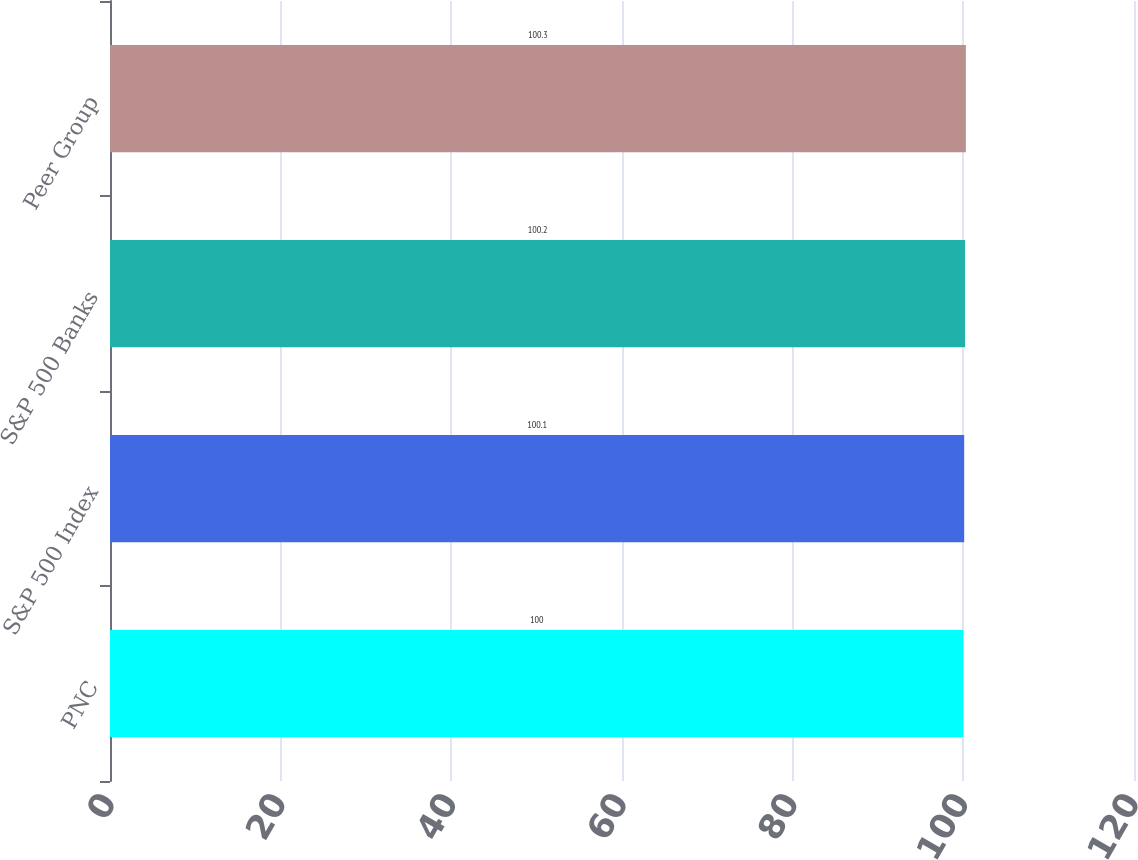<chart> <loc_0><loc_0><loc_500><loc_500><bar_chart><fcel>PNC<fcel>S&P 500 Index<fcel>S&P 500 Banks<fcel>Peer Group<nl><fcel>100<fcel>100.1<fcel>100.2<fcel>100.3<nl></chart> 